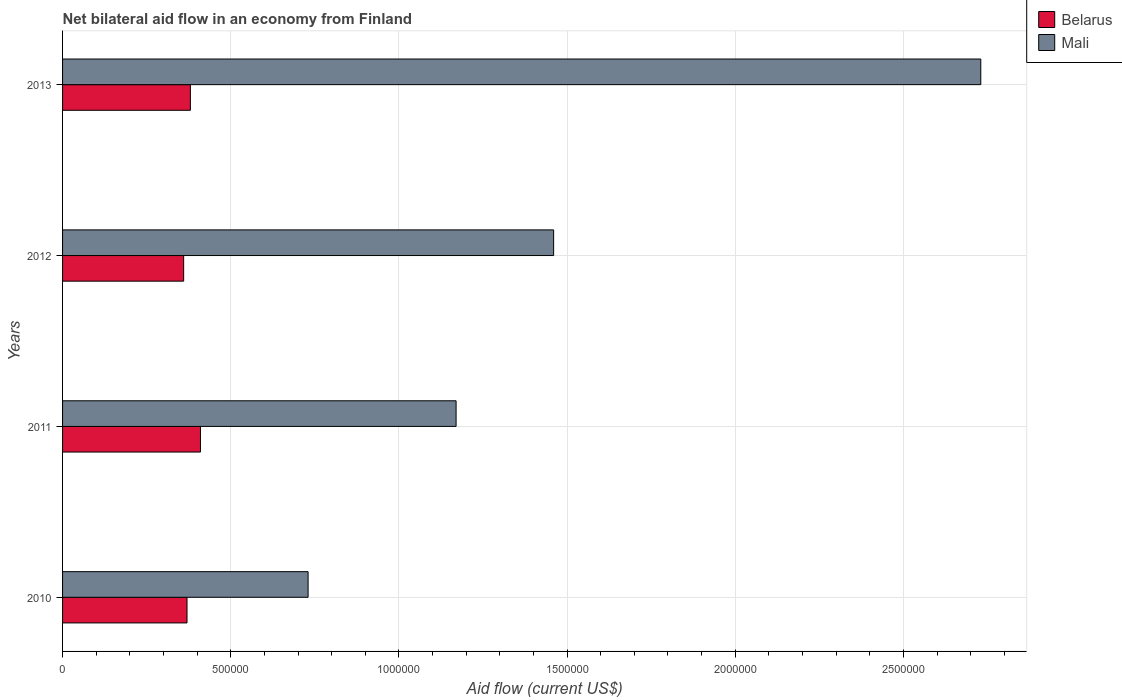Are the number of bars per tick equal to the number of legend labels?
Give a very brief answer. Yes. How many bars are there on the 1st tick from the top?
Provide a short and direct response. 2. What is the label of the 3rd group of bars from the top?
Provide a short and direct response. 2011. What is the total net bilateral aid flow in Mali in the graph?
Offer a very short reply. 6.09e+06. What is the difference between the net bilateral aid flow in Mali in 2011 and that in 2013?
Offer a very short reply. -1.56e+06. What is the difference between the net bilateral aid flow in Belarus in 2010 and the net bilateral aid flow in Mali in 2013?
Provide a short and direct response. -2.36e+06. In the year 2011, what is the difference between the net bilateral aid flow in Mali and net bilateral aid flow in Belarus?
Make the answer very short. 7.60e+05. In how many years, is the net bilateral aid flow in Belarus greater than 1900000 US$?
Your answer should be very brief. 0. What is the ratio of the net bilateral aid flow in Belarus in 2010 to that in 2013?
Provide a succinct answer. 0.97. Is the net bilateral aid flow in Mali in 2012 less than that in 2013?
Give a very brief answer. Yes. What is the difference between the highest and the second highest net bilateral aid flow in Mali?
Offer a terse response. 1.27e+06. What is the difference between the highest and the lowest net bilateral aid flow in Mali?
Offer a very short reply. 2.00e+06. Is the sum of the net bilateral aid flow in Mali in 2012 and 2013 greater than the maximum net bilateral aid flow in Belarus across all years?
Your response must be concise. Yes. What does the 2nd bar from the top in 2012 represents?
Make the answer very short. Belarus. What does the 1st bar from the bottom in 2012 represents?
Provide a succinct answer. Belarus. Are all the bars in the graph horizontal?
Your response must be concise. Yes. What is the difference between two consecutive major ticks on the X-axis?
Your answer should be compact. 5.00e+05. Are the values on the major ticks of X-axis written in scientific E-notation?
Provide a short and direct response. No. Does the graph contain any zero values?
Offer a terse response. No. Does the graph contain grids?
Offer a very short reply. Yes. Where does the legend appear in the graph?
Your response must be concise. Top right. How many legend labels are there?
Your answer should be very brief. 2. What is the title of the graph?
Provide a short and direct response. Net bilateral aid flow in an economy from Finland. Does "Central African Republic" appear as one of the legend labels in the graph?
Your answer should be compact. No. What is the label or title of the X-axis?
Ensure brevity in your answer.  Aid flow (current US$). What is the label or title of the Y-axis?
Provide a succinct answer. Years. What is the Aid flow (current US$) in Mali in 2010?
Provide a succinct answer. 7.30e+05. What is the Aid flow (current US$) in Mali in 2011?
Ensure brevity in your answer.  1.17e+06. What is the Aid flow (current US$) in Belarus in 2012?
Provide a short and direct response. 3.60e+05. What is the Aid flow (current US$) in Mali in 2012?
Ensure brevity in your answer.  1.46e+06. What is the Aid flow (current US$) of Belarus in 2013?
Make the answer very short. 3.80e+05. What is the Aid flow (current US$) in Mali in 2013?
Provide a short and direct response. 2.73e+06. Across all years, what is the maximum Aid flow (current US$) in Mali?
Give a very brief answer. 2.73e+06. Across all years, what is the minimum Aid flow (current US$) in Mali?
Keep it short and to the point. 7.30e+05. What is the total Aid flow (current US$) of Belarus in the graph?
Offer a terse response. 1.52e+06. What is the total Aid flow (current US$) of Mali in the graph?
Offer a very short reply. 6.09e+06. What is the difference between the Aid flow (current US$) of Mali in 2010 and that in 2011?
Your response must be concise. -4.40e+05. What is the difference between the Aid flow (current US$) in Belarus in 2010 and that in 2012?
Your answer should be compact. 10000. What is the difference between the Aid flow (current US$) of Mali in 2010 and that in 2012?
Your answer should be very brief. -7.30e+05. What is the difference between the Aid flow (current US$) of Mali in 2010 and that in 2013?
Keep it short and to the point. -2.00e+06. What is the difference between the Aid flow (current US$) in Mali in 2011 and that in 2012?
Give a very brief answer. -2.90e+05. What is the difference between the Aid flow (current US$) in Belarus in 2011 and that in 2013?
Give a very brief answer. 3.00e+04. What is the difference between the Aid flow (current US$) of Mali in 2011 and that in 2013?
Ensure brevity in your answer.  -1.56e+06. What is the difference between the Aid flow (current US$) in Mali in 2012 and that in 2013?
Your response must be concise. -1.27e+06. What is the difference between the Aid flow (current US$) of Belarus in 2010 and the Aid flow (current US$) of Mali in 2011?
Ensure brevity in your answer.  -8.00e+05. What is the difference between the Aid flow (current US$) of Belarus in 2010 and the Aid flow (current US$) of Mali in 2012?
Give a very brief answer. -1.09e+06. What is the difference between the Aid flow (current US$) of Belarus in 2010 and the Aid flow (current US$) of Mali in 2013?
Keep it short and to the point. -2.36e+06. What is the difference between the Aid flow (current US$) of Belarus in 2011 and the Aid flow (current US$) of Mali in 2012?
Provide a short and direct response. -1.05e+06. What is the difference between the Aid flow (current US$) of Belarus in 2011 and the Aid flow (current US$) of Mali in 2013?
Offer a very short reply. -2.32e+06. What is the difference between the Aid flow (current US$) in Belarus in 2012 and the Aid flow (current US$) in Mali in 2013?
Provide a succinct answer. -2.37e+06. What is the average Aid flow (current US$) in Mali per year?
Your answer should be very brief. 1.52e+06. In the year 2010, what is the difference between the Aid flow (current US$) in Belarus and Aid flow (current US$) in Mali?
Your answer should be very brief. -3.60e+05. In the year 2011, what is the difference between the Aid flow (current US$) of Belarus and Aid flow (current US$) of Mali?
Keep it short and to the point. -7.60e+05. In the year 2012, what is the difference between the Aid flow (current US$) of Belarus and Aid flow (current US$) of Mali?
Offer a very short reply. -1.10e+06. In the year 2013, what is the difference between the Aid flow (current US$) of Belarus and Aid flow (current US$) of Mali?
Provide a succinct answer. -2.35e+06. What is the ratio of the Aid flow (current US$) of Belarus in 2010 to that in 2011?
Give a very brief answer. 0.9. What is the ratio of the Aid flow (current US$) in Mali in 2010 to that in 2011?
Provide a short and direct response. 0.62. What is the ratio of the Aid flow (current US$) of Belarus in 2010 to that in 2012?
Your answer should be very brief. 1.03. What is the ratio of the Aid flow (current US$) of Mali in 2010 to that in 2012?
Your answer should be compact. 0.5. What is the ratio of the Aid flow (current US$) of Belarus in 2010 to that in 2013?
Provide a short and direct response. 0.97. What is the ratio of the Aid flow (current US$) of Mali in 2010 to that in 2013?
Offer a terse response. 0.27. What is the ratio of the Aid flow (current US$) of Belarus in 2011 to that in 2012?
Provide a succinct answer. 1.14. What is the ratio of the Aid flow (current US$) in Mali in 2011 to that in 2012?
Offer a very short reply. 0.8. What is the ratio of the Aid flow (current US$) in Belarus in 2011 to that in 2013?
Your answer should be compact. 1.08. What is the ratio of the Aid flow (current US$) in Mali in 2011 to that in 2013?
Provide a short and direct response. 0.43. What is the ratio of the Aid flow (current US$) in Belarus in 2012 to that in 2013?
Offer a very short reply. 0.95. What is the ratio of the Aid flow (current US$) of Mali in 2012 to that in 2013?
Keep it short and to the point. 0.53. What is the difference between the highest and the second highest Aid flow (current US$) in Mali?
Ensure brevity in your answer.  1.27e+06. What is the difference between the highest and the lowest Aid flow (current US$) in Belarus?
Provide a short and direct response. 5.00e+04. What is the difference between the highest and the lowest Aid flow (current US$) of Mali?
Keep it short and to the point. 2.00e+06. 